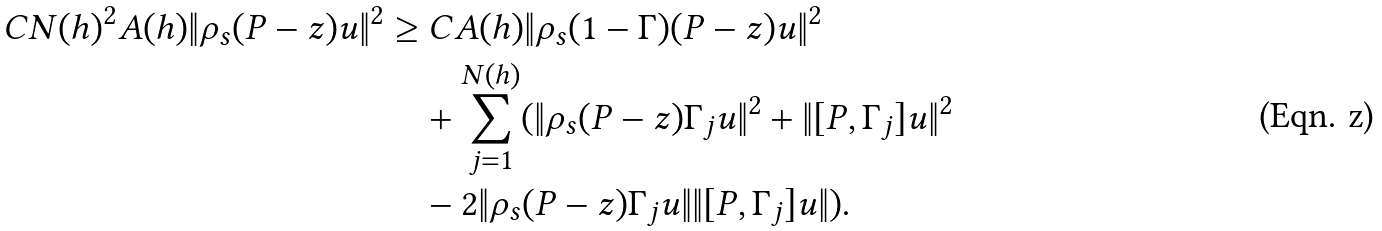<formula> <loc_0><loc_0><loc_500><loc_500>C N ( h ) ^ { 2 } A ( h ) \| \rho _ { s } ( P - z ) u \| ^ { 2 } & \geq C A ( h ) \| \rho _ { s } ( 1 - \Gamma ) ( P - z ) u \| ^ { 2 } \\ & \quad + \sum _ { j = 1 } ^ { N ( h ) } ( \| \rho _ { s } ( P - z ) \Gamma _ { j } u \| ^ { 2 } + \| [ P , \Gamma _ { j } ] u \| ^ { 2 } \\ & \quad - 2 \| \rho _ { s } ( P - z ) \Gamma _ { j } u \| \| [ P , \Gamma _ { j } ] u \| ) .</formula> 